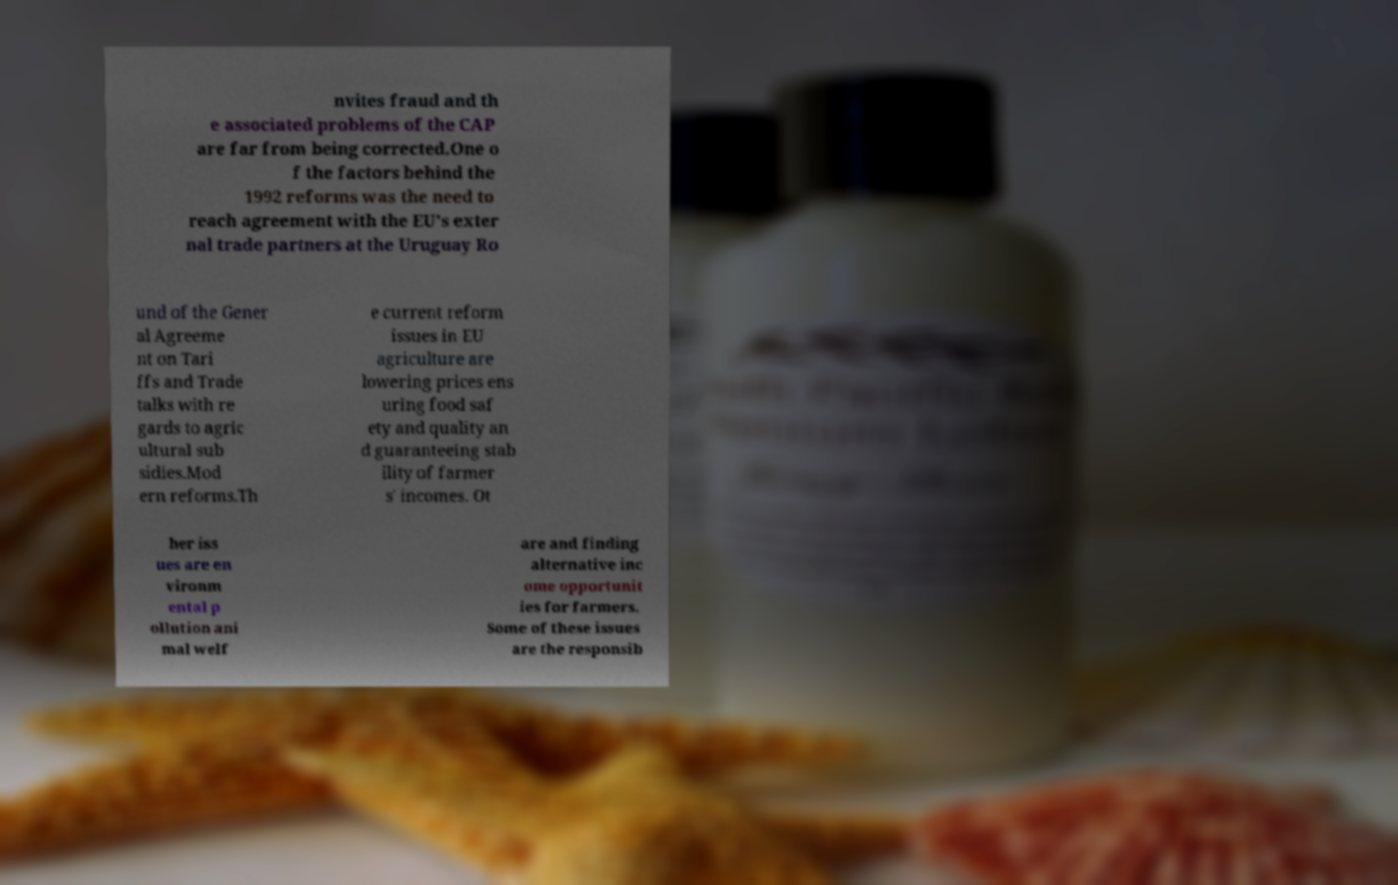Please read and relay the text visible in this image. What does it say? nvites fraud and th e associated problems of the CAP are far from being corrected.One o f the factors behind the 1992 reforms was the need to reach agreement with the EU's exter nal trade partners at the Uruguay Ro und of the Gener al Agreeme nt on Tari ffs and Trade talks with re gards to agric ultural sub sidies.Mod ern reforms.Th e current reform issues in EU agriculture are lowering prices ens uring food saf ety and quality an d guaranteeing stab ility of farmer s' incomes. Ot her iss ues are en vironm ental p ollution ani mal welf are and finding alternative inc ome opportunit ies for farmers. Some of these issues are the responsib 